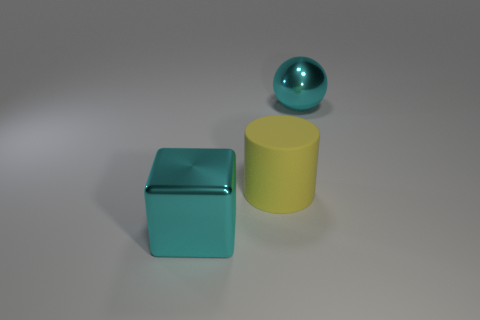Add 1 tiny objects. How many objects exist? 4 Subtract all cubes. How many objects are left? 2 Subtract 0 gray blocks. How many objects are left? 3 Subtract all cyan metal spheres. Subtract all cyan metal balls. How many objects are left? 1 Add 1 matte objects. How many matte objects are left? 2 Add 1 cylinders. How many cylinders exist? 2 